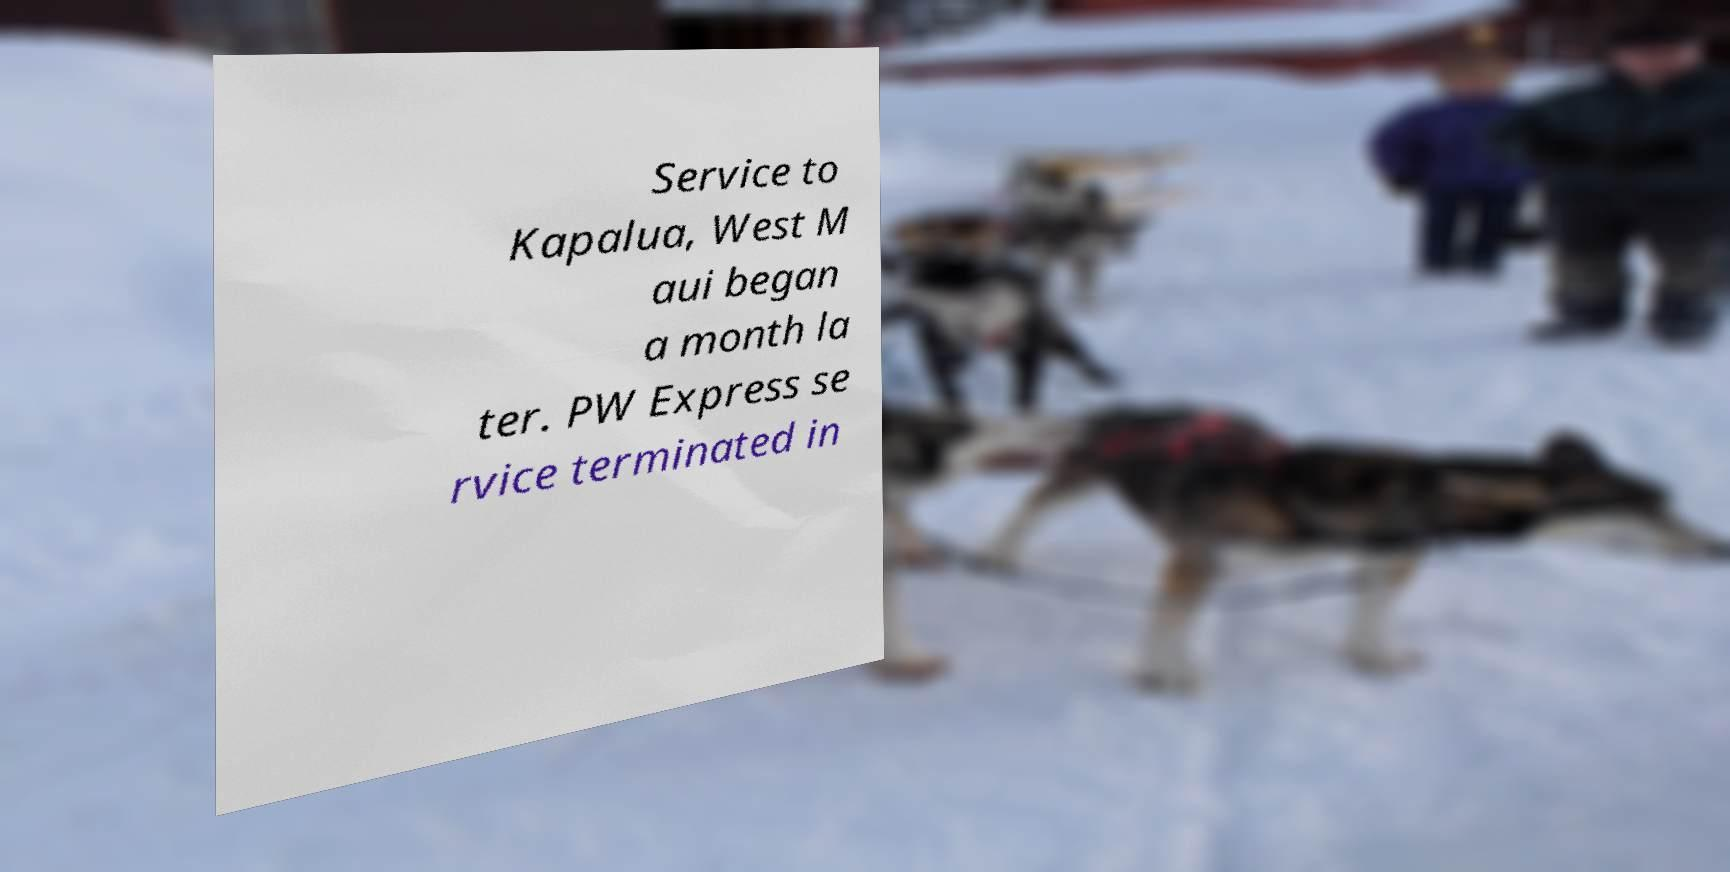I need the written content from this picture converted into text. Can you do that? Service to Kapalua, West M aui began a month la ter. PW Express se rvice terminated in 